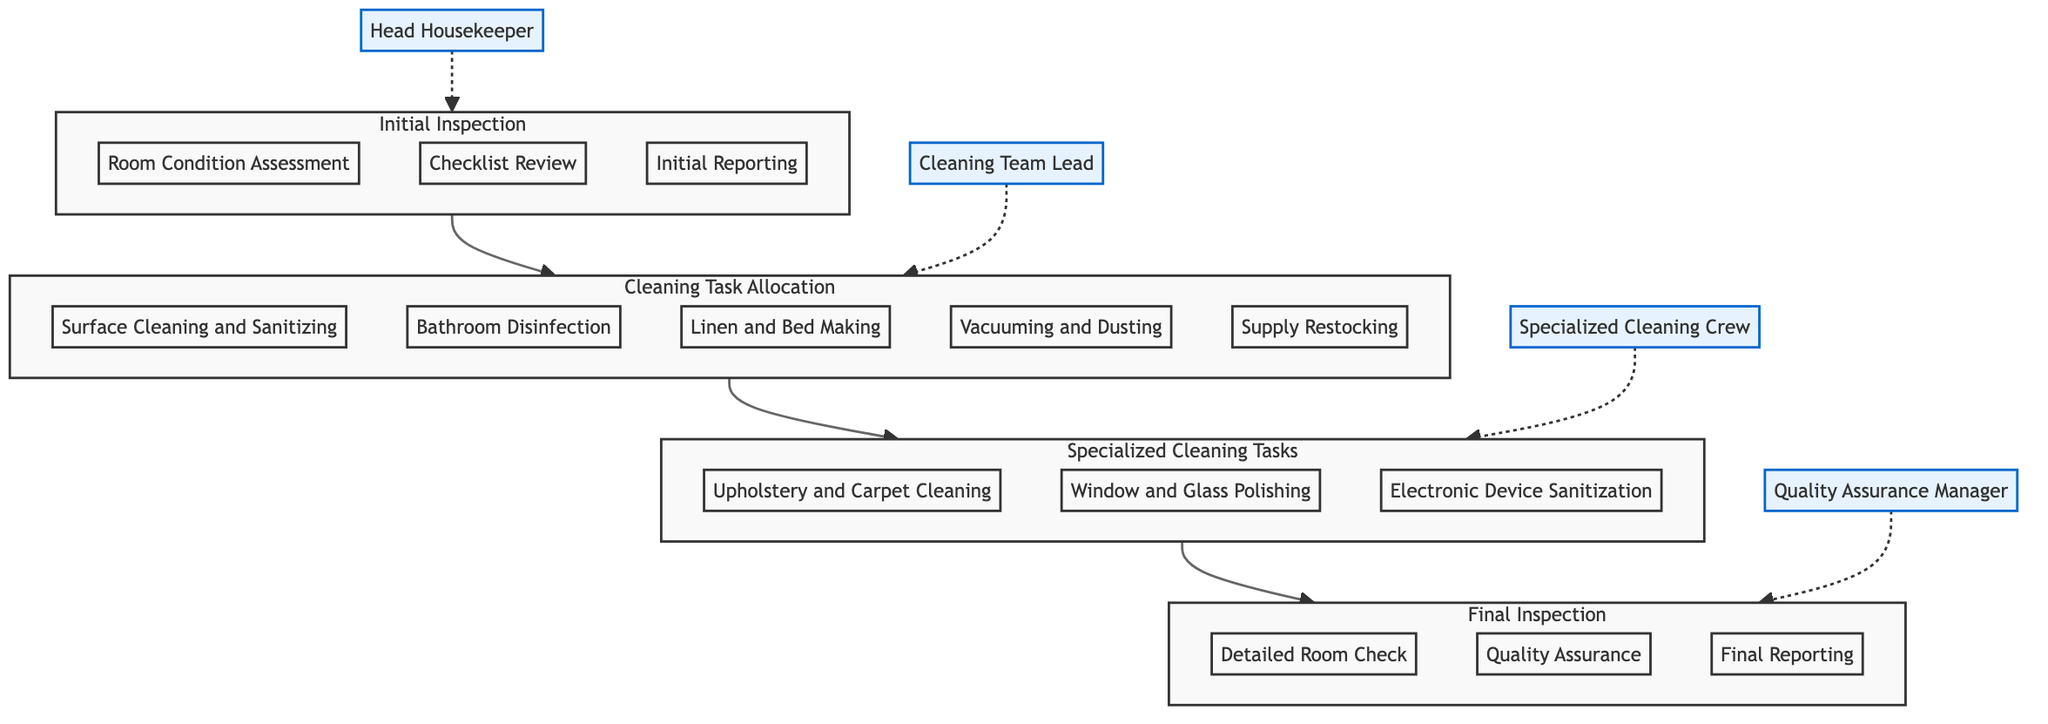What is the responsible entity for the Initial Inspection? The diagram indicates that the responsible entity for the Initial Inspection is the Head Housekeeper.
Answer: Head Housekeeper How many blocks are present in the diagram? The diagram contains four blocks: Initial Inspection, Cleaning Task Allocation, Specialized Cleaning Tasks, and Final Inspection.
Answer: 4 Which block follows Cleaning Task Allocation? Based on the flow of the diagram, the block that follows Cleaning Task Allocation is Specialized Cleaning Tasks.
Answer: Specialized Cleaning Tasks What are the elements listed under Final Inspection? The elements listed under Final Inspection are Detailed Room Check, Quality Assurance, and Final Reporting, as shown in the block.
Answer: Detailed Room Check, Quality Assurance, Final Reporting Name a task of the Specialized Cleaning Crew. The diagram indicates that tasks of the Specialized Cleaning Crew include Upholstery and Carpet Cleaning, Window and Glass Polishing, and Electronic Device Sanitization. One example is Upholstery and Carpet Cleaning.
Answer: Upholstery and Carpet Cleaning Which block initiates the flow towards Cleaning Task Allocation? The flow into Cleaning Task Allocation begins with the Initial Inspection block according to the diagram.
Answer: Initial Inspection How many tasks are assigned to the Cleaning Team Lead? The Cleaning Team Lead is assigned five tasks: Surface Cleaning and Sanitizing, Bathroom Disinfection, Linen and Bed Making, Vacuuming and Dusting, and Supply Restocking.
Answer: 5 What is the purpose of the Final Inspection block? The purpose of the Final Inspection block includes conducting a Detailed Room Check, performing Quality Assurance, and preparing a Final Reporting as per the diagram.
Answer: Detailed Room Check, Quality Assurance, Final Reporting Which block represents the specialized cleaning tasks? The block representing the specialized cleaning tasks is titled Specialized Cleaning Tasks, as indicated in the diagram.
Answer: Specialized Cleaning Tasks 